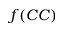Convert formula to latex. <formula><loc_0><loc_0><loc_500><loc_500>f ( C C )</formula> 